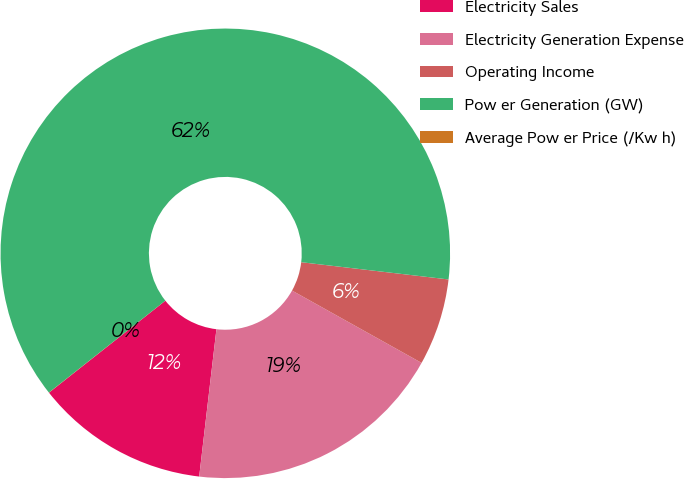<chart> <loc_0><loc_0><loc_500><loc_500><pie_chart><fcel>Electricity Sales<fcel>Electricity Generation Expense<fcel>Operating Income<fcel>Pow er Generation (GW)<fcel>Average Pow er Price (/Kw h)<nl><fcel>12.5%<fcel>18.75%<fcel>6.25%<fcel>62.49%<fcel>0.01%<nl></chart> 